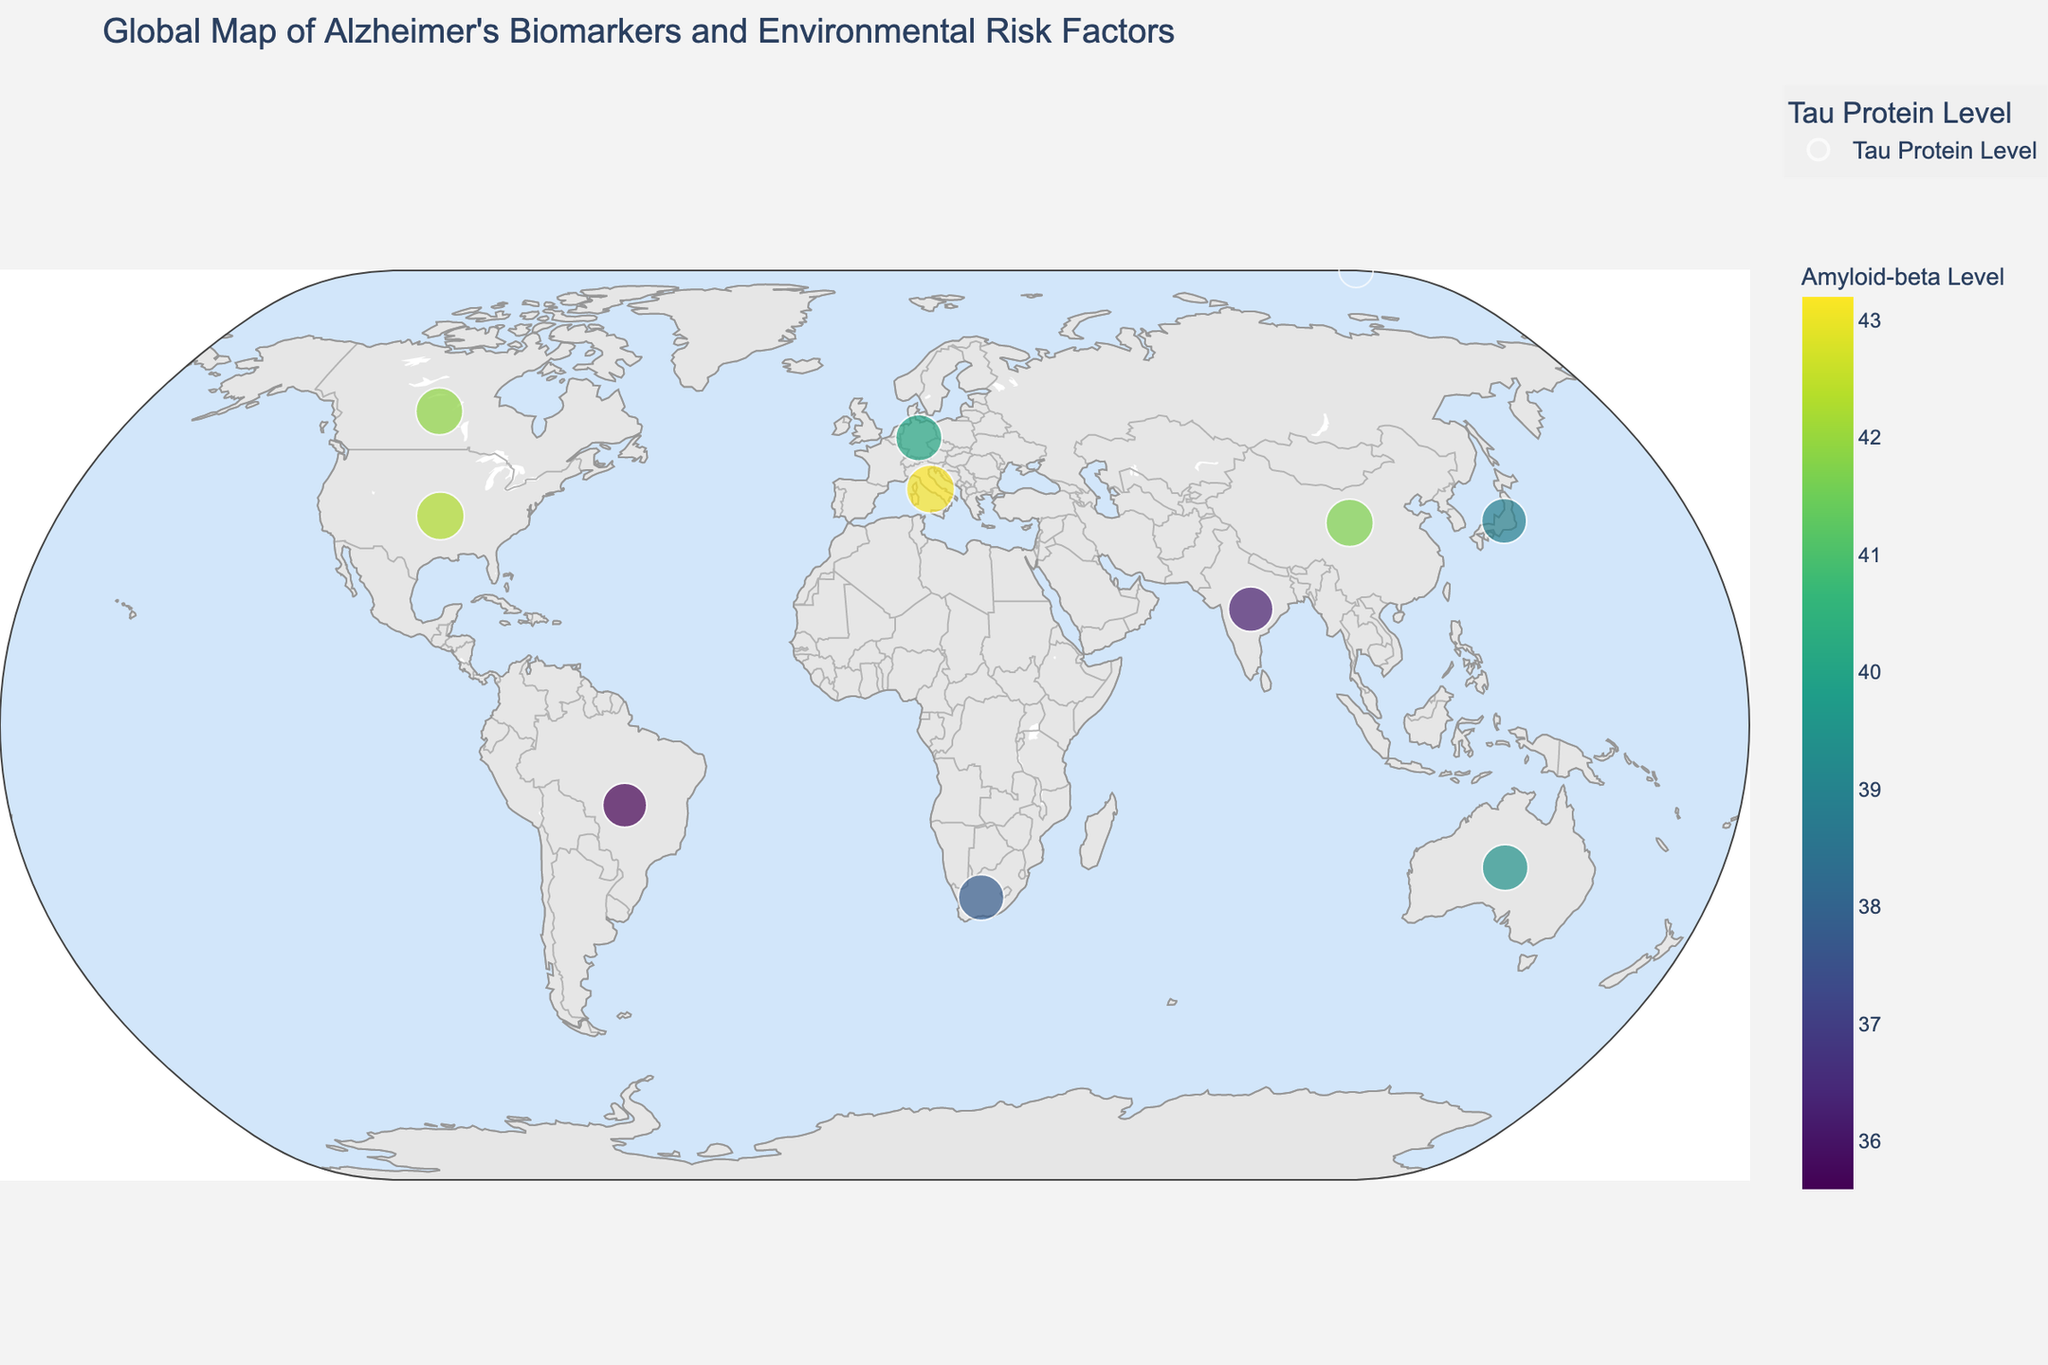How many countries are represented in the figure? Count the number of different countries (or data points) present on the map. Each point represents a unique country.
Answer: 10 Which country has the highest Amyloid-beta Level according to the figure? Look for the country with the darkest color on the map since the color represents the Amyloid-beta Level. Italy is the darkest, indicating it has the highest level
Answer: Italy Compare the Tau Protein Level between the USA and China. Which country has a higher level? Hover over the points for USA and China, and note the Tau Protein Levels. USA has a Tau Protein Level of 58.7, while China has a level of 57.9. Thus, the USA has a higher level.
Answer: USA What is the relationship between Air Pollution Index and Amyloid-beta Level for the countries in the figure? Observe the color (representing Amyloid-beta Level) and compare it with the Air Pollution Index (visible in the hover data). Generally, higher Air Pollution Indices (China and India) correspond to higher Amyloid-beta Levels (darker colors).
Answer: Higher Air Pollution Index, Higher Amyloid-beta Level Which country has the lowest Tau Protein Level, and what is its corresponding Amyloid-beta Level? Identify the country with the smallest size marker as size represents Tau Protein Level. Brazil has the smallest size marker indicating the lowest Tau Protein Level, with a corresponding Amyloid-beta Level of 35.6.
Answer: Brazil, 35.6 Is there a country where the APOE4 Frequency is higher than 0.15 and has a relatively high Amyloid-beta Level? Check the hover data for countries where APOE4 Frequency is higher than 0.15 (Canada, Germany, and Italy). Among them, Italy has both a high APOE4 Frequency (0.17) and a high Amyloid-beta Level (43.2).
Answer: Italy Compare Australia and South Africa in terms of their Pesticide Exposure Level and its possible impact on Alzheimer’s biomarkers. Hover over Australia and South Africa on the map to compare their Pesticide Exposure Levels. Australia has a level of 2.7, and South Africa has a level of 3.9. South Africa has higher Pesticide Exposure and slightly higher Amyloid-beta and Tau Protein Levels than Australia.
Answer: South Africa: Higher Pesticide Exposure and Biomarkers What color represents countries with an Amyloid-beta Level around 40? Look up the color scale on the map to find the color corresponding to an Amyloid-beta Level of around 40. The color is mid-green.
Answer: Mid-green Calculate the average Amyloid-beta Level of all the countries displayed. Add the Amyloid-beta Levels (42.3, 38.9, 40.1, 35.6, 36.2, 39.5, 37.8, 41.7, 41.9, 43.2) and divide by the number of countries (10). Sum is 397.2, and the average is 39.72
Answer: 39.72 Which country has both a high APOE4 Frequency and low Air Pollution Index, and what is its Tau Protein Level? Identify countries with high APOE4 Frequency (greater than 0.12) and low Air Pollution Index (lower than 40). Canada fits this criterion with an APOE4 Frequency of 0.16 and an Air Pollution Index of 33. Its Tau Protein Level is 56.8.
Answer: Canada, 56.8 